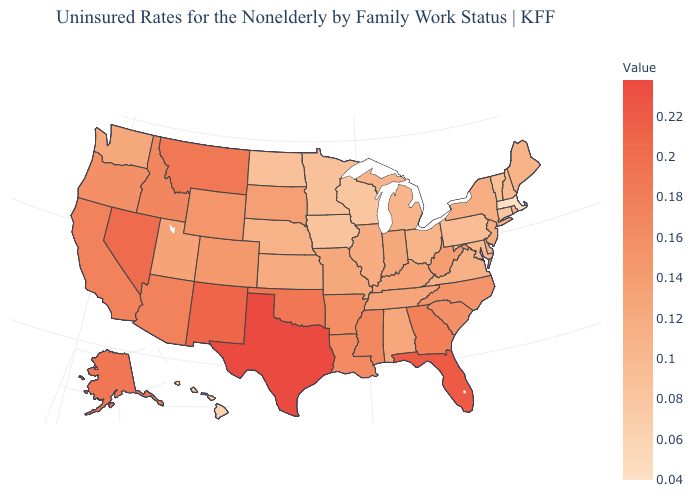Does Texas have the highest value in the USA?
Quick response, please. Yes. Does Tennessee have a lower value than Alaska?
Quick response, please. Yes. Which states have the lowest value in the USA?
Write a very short answer. Massachusetts. Does Nebraska have a higher value than Montana?
Answer briefly. No. Among the states that border Illinois , does Wisconsin have the lowest value?
Be succinct. Yes. Is the legend a continuous bar?
Write a very short answer. Yes. 